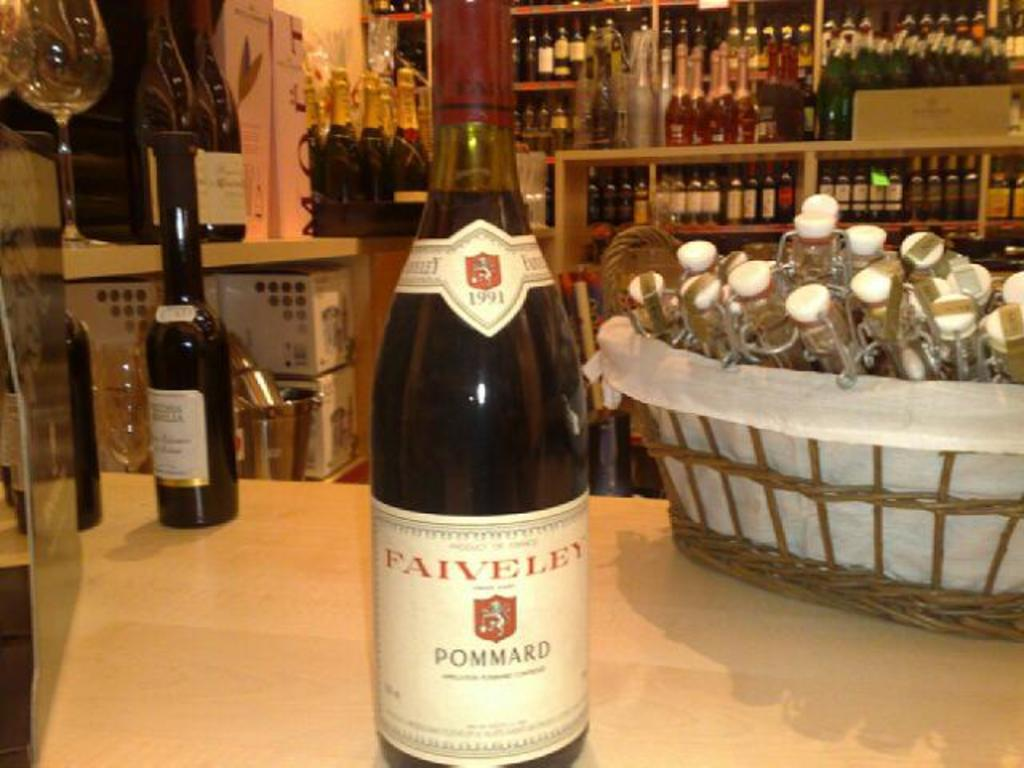<image>
Write a terse but informative summary of the picture. A bottle of Paiveley with other bottles on the tables and shelves behind it. 